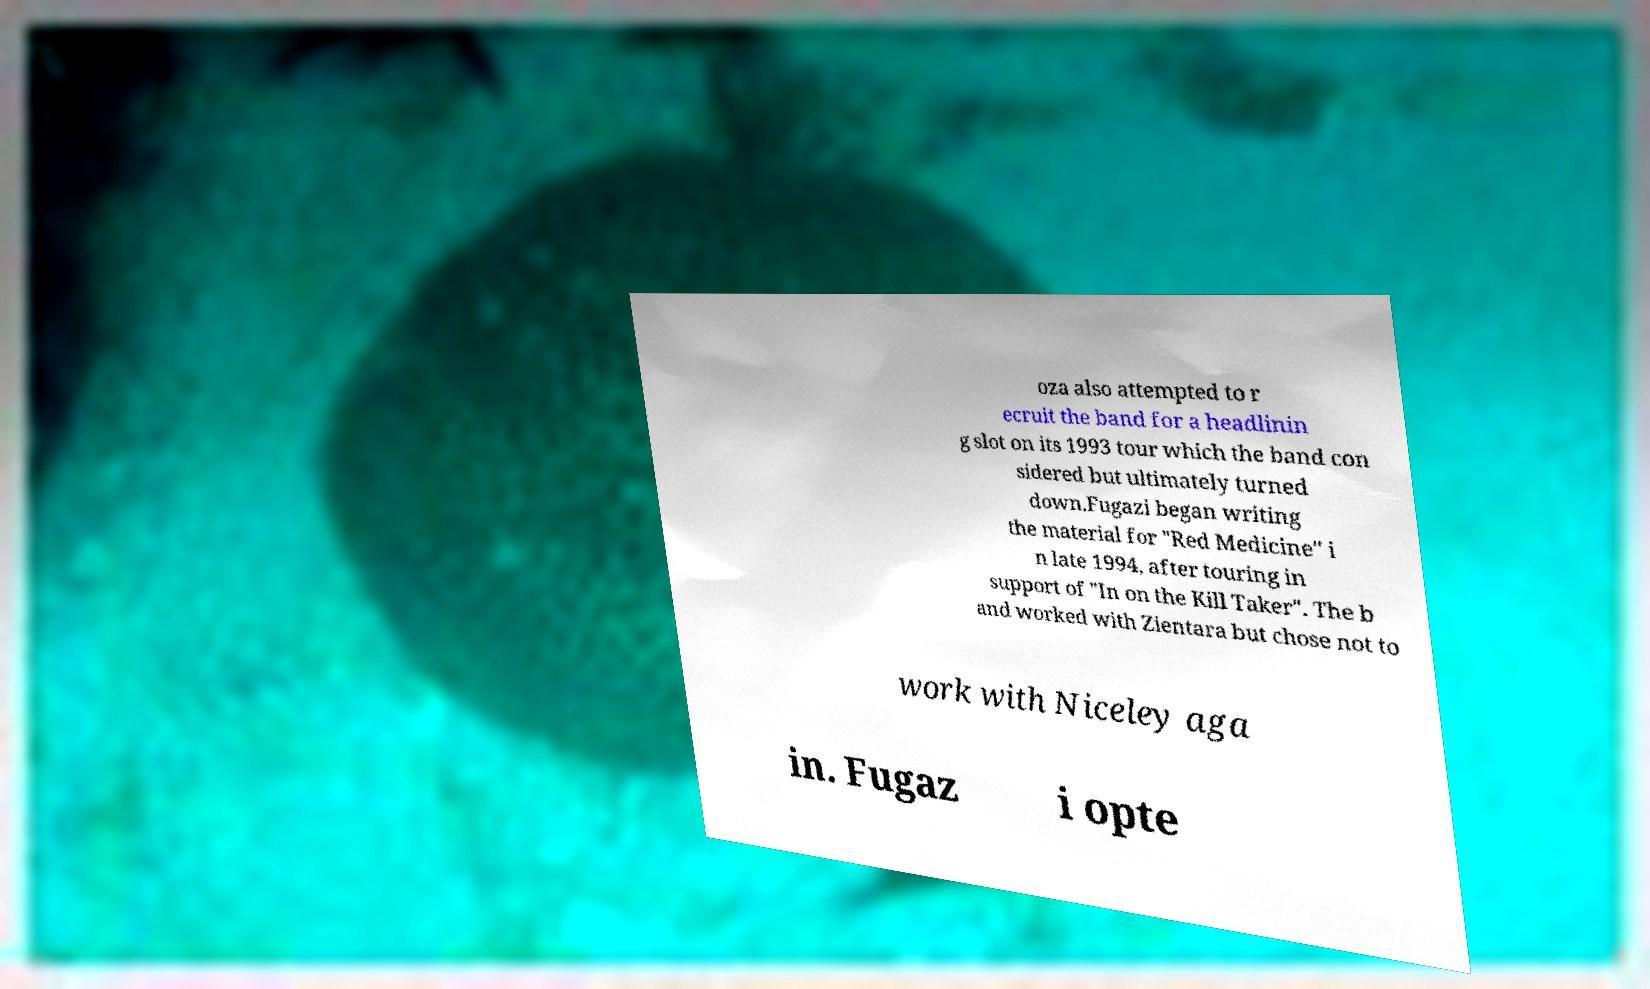What messages or text are displayed in this image? I need them in a readable, typed format. oza also attempted to r ecruit the band for a headlinin g slot on its 1993 tour which the band con sidered but ultimately turned down.Fugazi began writing the material for "Red Medicine" i n late 1994, after touring in support of "In on the Kill Taker". The b and worked with Zientara but chose not to work with Niceley aga in. Fugaz i opte 